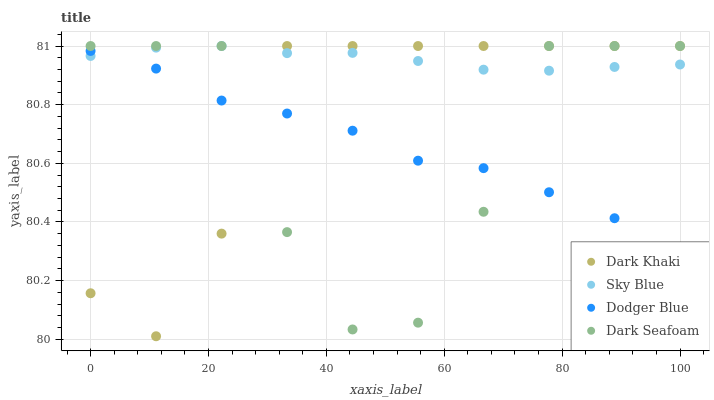Does Dark Seafoam have the minimum area under the curve?
Answer yes or no. Yes. Does Sky Blue have the maximum area under the curve?
Answer yes or no. Yes. Does Sky Blue have the minimum area under the curve?
Answer yes or no. No. Does Dark Seafoam have the maximum area under the curve?
Answer yes or no. No. Is Sky Blue the smoothest?
Answer yes or no. Yes. Is Dark Seafoam the roughest?
Answer yes or no. Yes. Is Dark Seafoam the smoothest?
Answer yes or no. No. Is Sky Blue the roughest?
Answer yes or no. No. Does Dark Khaki have the lowest value?
Answer yes or no. Yes. Does Dark Seafoam have the lowest value?
Answer yes or no. No. Does Dark Seafoam have the highest value?
Answer yes or no. Yes. Does Dodger Blue have the highest value?
Answer yes or no. No. Does Dark Seafoam intersect Sky Blue?
Answer yes or no. Yes. Is Dark Seafoam less than Sky Blue?
Answer yes or no. No. Is Dark Seafoam greater than Sky Blue?
Answer yes or no. No. 